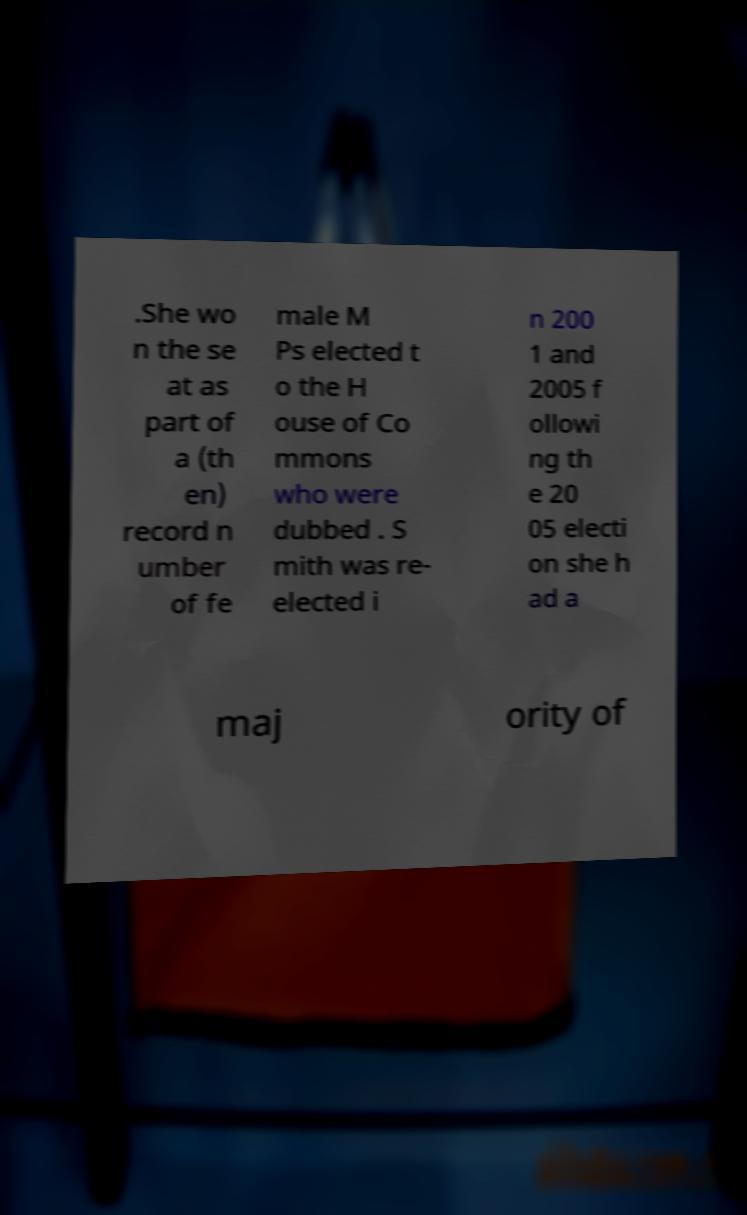Could you assist in decoding the text presented in this image and type it out clearly? .She wo n the se at as part of a (th en) record n umber of fe male M Ps elected t o the H ouse of Co mmons who were dubbed . S mith was re- elected i n 200 1 and 2005 f ollowi ng th e 20 05 electi on she h ad a maj ority of 